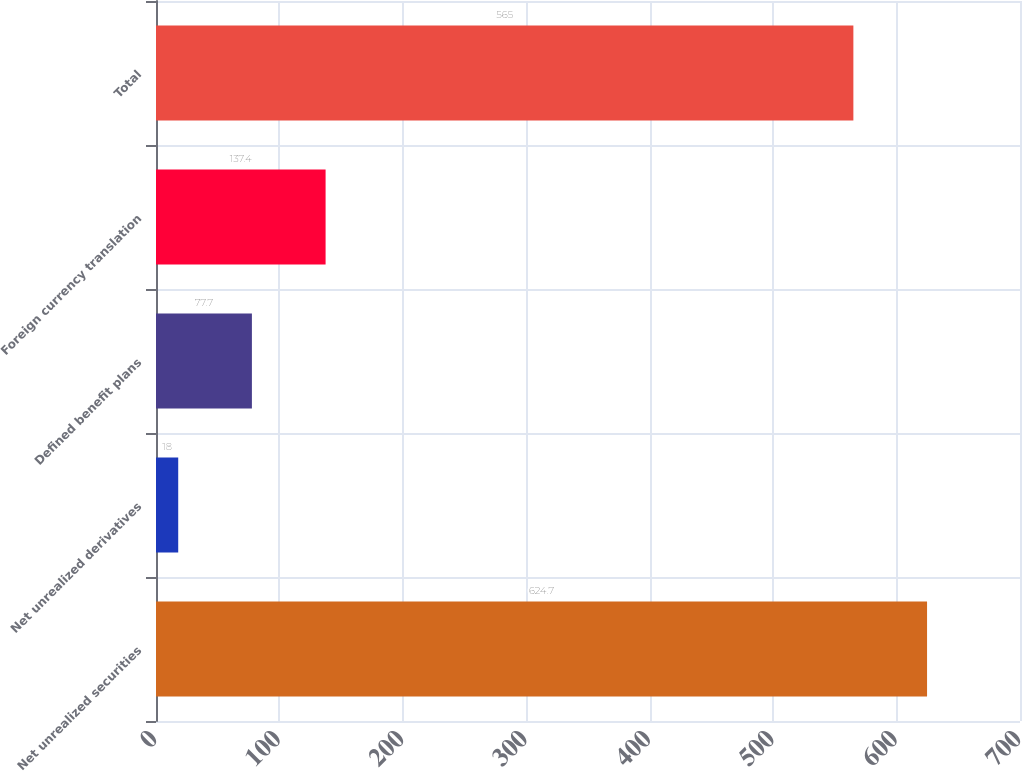Convert chart. <chart><loc_0><loc_0><loc_500><loc_500><bar_chart><fcel>Net unrealized securities<fcel>Net unrealized derivatives<fcel>Defined benefit plans<fcel>Foreign currency translation<fcel>Total<nl><fcel>624.7<fcel>18<fcel>77.7<fcel>137.4<fcel>565<nl></chart> 